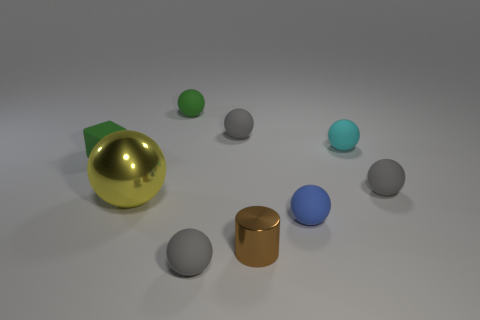Subtract all red blocks. How many gray spheres are left? 3 Subtract all yellow spheres. How many spheres are left? 6 Subtract all small blue balls. How many balls are left? 6 Subtract all blue balls. Subtract all purple cylinders. How many balls are left? 6 Subtract all cubes. How many objects are left? 8 Add 6 metal things. How many metal things are left? 8 Add 7 tiny blue rubber objects. How many tiny blue rubber objects exist? 8 Subtract 0 cyan cubes. How many objects are left? 9 Subtract all tiny rubber cubes. Subtract all gray balls. How many objects are left? 5 